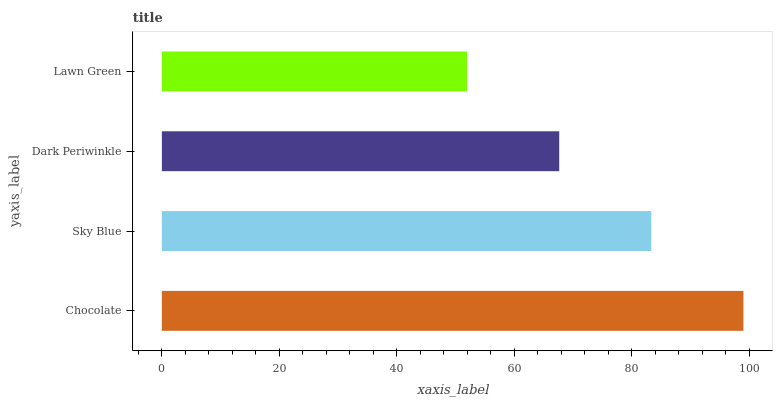Is Lawn Green the minimum?
Answer yes or no. Yes. Is Chocolate the maximum?
Answer yes or no. Yes. Is Sky Blue the minimum?
Answer yes or no. No. Is Sky Blue the maximum?
Answer yes or no. No. Is Chocolate greater than Sky Blue?
Answer yes or no. Yes. Is Sky Blue less than Chocolate?
Answer yes or no. Yes. Is Sky Blue greater than Chocolate?
Answer yes or no. No. Is Chocolate less than Sky Blue?
Answer yes or no. No. Is Sky Blue the high median?
Answer yes or no. Yes. Is Dark Periwinkle the low median?
Answer yes or no. Yes. Is Lawn Green the high median?
Answer yes or no. No. Is Sky Blue the low median?
Answer yes or no. No. 